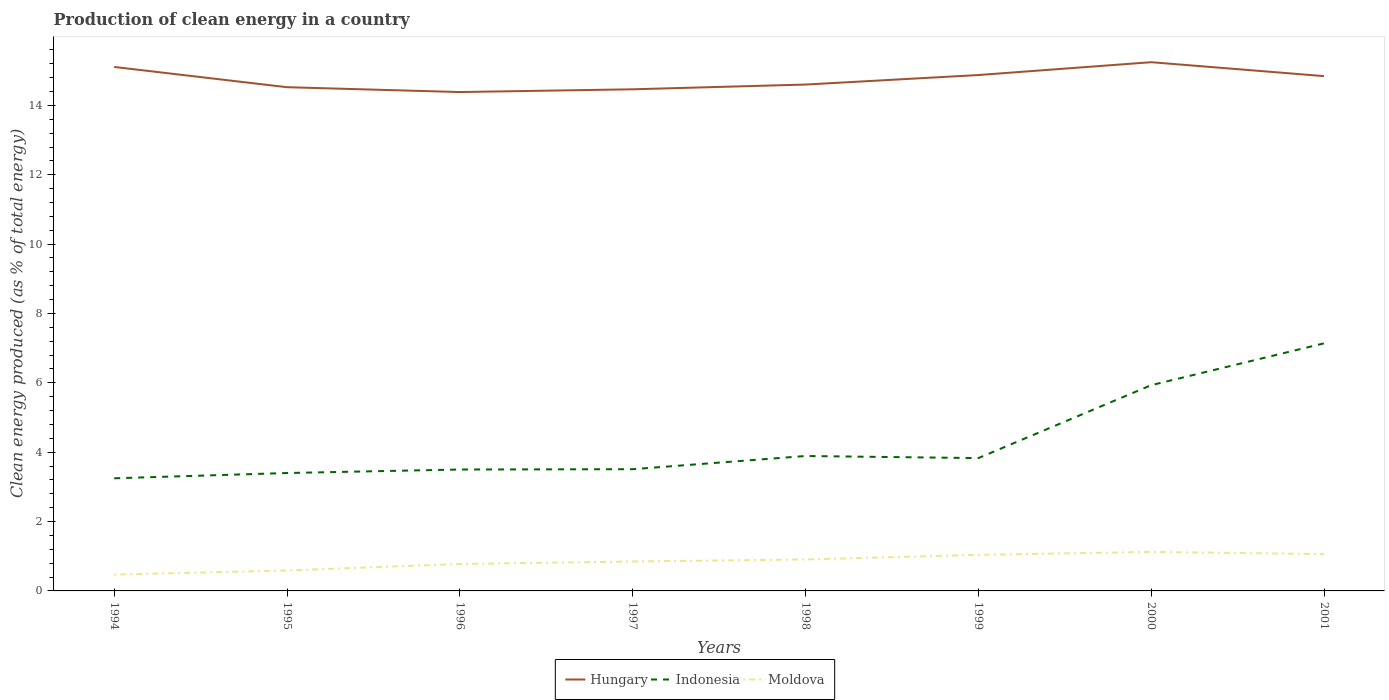Does the line corresponding to Hungary intersect with the line corresponding to Moldova?
Offer a very short reply. No. Across all years, what is the maximum percentage of clean energy produced in Indonesia?
Keep it short and to the point. 3.25. What is the total percentage of clean energy produced in Moldova in the graph?
Keep it short and to the point. -0.26. What is the difference between the highest and the second highest percentage of clean energy produced in Moldova?
Keep it short and to the point. 0.65. What is the difference between the highest and the lowest percentage of clean energy produced in Hungary?
Ensure brevity in your answer.  4. How many years are there in the graph?
Keep it short and to the point. 8. Are the values on the major ticks of Y-axis written in scientific E-notation?
Give a very brief answer. No. Does the graph contain any zero values?
Keep it short and to the point. No. Does the graph contain grids?
Your answer should be very brief. No. How many legend labels are there?
Provide a short and direct response. 3. How are the legend labels stacked?
Your response must be concise. Horizontal. What is the title of the graph?
Your answer should be compact. Production of clean energy in a country. What is the label or title of the X-axis?
Offer a very short reply. Years. What is the label or title of the Y-axis?
Offer a terse response. Clean energy produced (as % of total energy). What is the Clean energy produced (as % of total energy) in Hungary in 1994?
Your answer should be compact. 15.11. What is the Clean energy produced (as % of total energy) in Indonesia in 1994?
Your response must be concise. 3.25. What is the Clean energy produced (as % of total energy) in Moldova in 1994?
Your response must be concise. 0.47. What is the Clean energy produced (as % of total energy) in Hungary in 1995?
Offer a very short reply. 14.52. What is the Clean energy produced (as % of total energy) in Indonesia in 1995?
Keep it short and to the point. 3.4. What is the Clean energy produced (as % of total energy) in Moldova in 1995?
Give a very brief answer. 0.59. What is the Clean energy produced (as % of total energy) in Hungary in 1996?
Ensure brevity in your answer.  14.39. What is the Clean energy produced (as % of total energy) in Indonesia in 1996?
Your answer should be very brief. 3.5. What is the Clean energy produced (as % of total energy) in Moldova in 1996?
Provide a short and direct response. 0.78. What is the Clean energy produced (as % of total energy) in Hungary in 1997?
Make the answer very short. 14.46. What is the Clean energy produced (as % of total energy) of Indonesia in 1997?
Provide a succinct answer. 3.51. What is the Clean energy produced (as % of total energy) of Moldova in 1997?
Keep it short and to the point. 0.85. What is the Clean energy produced (as % of total energy) of Hungary in 1998?
Your answer should be very brief. 14.6. What is the Clean energy produced (as % of total energy) in Indonesia in 1998?
Keep it short and to the point. 3.89. What is the Clean energy produced (as % of total energy) in Moldova in 1998?
Give a very brief answer. 0.91. What is the Clean energy produced (as % of total energy) of Hungary in 1999?
Your response must be concise. 14.88. What is the Clean energy produced (as % of total energy) in Indonesia in 1999?
Offer a terse response. 3.83. What is the Clean energy produced (as % of total energy) in Moldova in 1999?
Keep it short and to the point. 1.04. What is the Clean energy produced (as % of total energy) of Hungary in 2000?
Your answer should be very brief. 15.25. What is the Clean energy produced (as % of total energy) in Indonesia in 2000?
Ensure brevity in your answer.  5.93. What is the Clean energy produced (as % of total energy) in Moldova in 2000?
Your answer should be compact. 1.12. What is the Clean energy produced (as % of total energy) in Hungary in 2001?
Keep it short and to the point. 14.84. What is the Clean energy produced (as % of total energy) in Indonesia in 2001?
Keep it short and to the point. 7.14. What is the Clean energy produced (as % of total energy) in Moldova in 2001?
Your answer should be compact. 1.06. Across all years, what is the maximum Clean energy produced (as % of total energy) of Hungary?
Your answer should be very brief. 15.25. Across all years, what is the maximum Clean energy produced (as % of total energy) of Indonesia?
Provide a succinct answer. 7.14. Across all years, what is the maximum Clean energy produced (as % of total energy) of Moldova?
Ensure brevity in your answer.  1.12. Across all years, what is the minimum Clean energy produced (as % of total energy) in Hungary?
Offer a terse response. 14.39. Across all years, what is the minimum Clean energy produced (as % of total energy) of Indonesia?
Provide a succinct answer. 3.25. Across all years, what is the minimum Clean energy produced (as % of total energy) of Moldova?
Offer a terse response. 0.47. What is the total Clean energy produced (as % of total energy) in Hungary in the graph?
Keep it short and to the point. 118.05. What is the total Clean energy produced (as % of total energy) in Indonesia in the graph?
Your answer should be compact. 34.45. What is the total Clean energy produced (as % of total energy) in Moldova in the graph?
Your response must be concise. 6.82. What is the difference between the Clean energy produced (as % of total energy) in Hungary in 1994 and that in 1995?
Keep it short and to the point. 0.58. What is the difference between the Clean energy produced (as % of total energy) of Indonesia in 1994 and that in 1995?
Offer a very short reply. -0.15. What is the difference between the Clean energy produced (as % of total energy) of Moldova in 1994 and that in 1995?
Give a very brief answer. -0.12. What is the difference between the Clean energy produced (as % of total energy) in Hungary in 1994 and that in 1996?
Provide a succinct answer. 0.72. What is the difference between the Clean energy produced (as % of total energy) in Indonesia in 1994 and that in 1996?
Ensure brevity in your answer.  -0.25. What is the difference between the Clean energy produced (as % of total energy) in Moldova in 1994 and that in 1996?
Your response must be concise. -0.31. What is the difference between the Clean energy produced (as % of total energy) of Hungary in 1994 and that in 1997?
Offer a terse response. 0.64. What is the difference between the Clean energy produced (as % of total energy) in Indonesia in 1994 and that in 1997?
Offer a terse response. -0.26. What is the difference between the Clean energy produced (as % of total energy) of Moldova in 1994 and that in 1997?
Your answer should be compact. -0.38. What is the difference between the Clean energy produced (as % of total energy) in Hungary in 1994 and that in 1998?
Offer a very short reply. 0.51. What is the difference between the Clean energy produced (as % of total energy) of Indonesia in 1994 and that in 1998?
Provide a succinct answer. -0.64. What is the difference between the Clean energy produced (as % of total energy) of Moldova in 1994 and that in 1998?
Your response must be concise. -0.44. What is the difference between the Clean energy produced (as % of total energy) of Hungary in 1994 and that in 1999?
Your response must be concise. 0.23. What is the difference between the Clean energy produced (as % of total energy) of Indonesia in 1994 and that in 1999?
Offer a terse response. -0.58. What is the difference between the Clean energy produced (as % of total energy) in Moldova in 1994 and that in 1999?
Provide a short and direct response. -0.57. What is the difference between the Clean energy produced (as % of total energy) of Hungary in 1994 and that in 2000?
Make the answer very short. -0.14. What is the difference between the Clean energy produced (as % of total energy) of Indonesia in 1994 and that in 2000?
Provide a short and direct response. -2.68. What is the difference between the Clean energy produced (as % of total energy) in Moldova in 1994 and that in 2000?
Your answer should be very brief. -0.65. What is the difference between the Clean energy produced (as % of total energy) of Hungary in 1994 and that in 2001?
Offer a very short reply. 0.26. What is the difference between the Clean energy produced (as % of total energy) of Indonesia in 1994 and that in 2001?
Your answer should be very brief. -3.89. What is the difference between the Clean energy produced (as % of total energy) in Moldova in 1994 and that in 2001?
Ensure brevity in your answer.  -0.59. What is the difference between the Clean energy produced (as % of total energy) of Hungary in 1995 and that in 1996?
Keep it short and to the point. 0.14. What is the difference between the Clean energy produced (as % of total energy) of Indonesia in 1995 and that in 1996?
Provide a short and direct response. -0.1. What is the difference between the Clean energy produced (as % of total energy) in Moldova in 1995 and that in 1996?
Your response must be concise. -0.19. What is the difference between the Clean energy produced (as % of total energy) in Hungary in 1995 and that in 1997?
Make the answer very short. 0.06. What is the difference between the Clean energy produced (as % of total energy) of Indonesia in 1995 and that in 1997?
Provide a short and direct response. -0.11. What is the difference between the Clean energy produced (as % of total energy) in Moldova in 1995 and that in 1997?
Make the answer very short. -0.26. What is the difference between the Clean energy produced (as % of total energy) in Hungary in 1995 and that in 1998?
Ensure brevity in your answer.  -0.08. What is the difference between the Clean energy produced (as % of total energy) in Indonesia in 1995 and that in 1998?
Ensure brevity in your answer.  -0.49. What is the difference between the Clean energy produced (as % of total energy) of Moldova in 1995 and that in 1998?
Ensure brevity in your answer.  -0.32. What is the difference between the Clean energy produced (as % of total energy) in Hungary in 1995 and that in 1999?
Your response must be concise. -0.35. What is the difference between the Clean energy produced (as % of total energy) in Indonesia in 1995 and that in 1999?
Provide a short and direct response. -0.43. What is the difference between the Clean energy produced (as % of total energy) in Moldova in 1995 and that in 1999?
Your answer should be compact. -0.45. What is the difference between the Clean energy produced (as % of total energy) in Hungary in 1995 and that in 2000?
Offer a very short reply. -0.72. What is the difference between the Clean energy produced (as % of total energy) in Indonesia in 1995 and that in 2000?
Provide a short and direct response. -2.53. What is the difference between the Clean energy produced (as % of total energy) of Moldova in 1995 and that in 2000?
Provide a succinct answer. -0.53. What is the difference between the Clean energy produced (as % of total energy) of Hungary in 1995 and that in 2001?
Ensure brevity in your answer.  -0.32. What is the difference between the Clean energy produced (as % of total energy) in Indonesia in 1995 and that in 2001?
Offer a terse response. -3.74. What is the difference between the Clean energy produced (as % of total energy) of Moldova in 1995 and that in 2001?
Your response must be concise. -0.47. What is the difference between the Clean energy produced (as % of total energy) of Hungary in 1996 and that in 1997?
Provide a short and direct response. -0.08. What is the difference between the Clean energy produced (as % of total energy) of Indonesia in 1996 and that in 1997?
Offer a terse response. -0.01. What is the difference between the Clean energy produced (as % of total energy) in Moldova in 1996 and that in 1997?
Your answer should be compact. -0.07. What is the difference between the Clean energy produced (as % of total energy) of Hungary in 1996 and that in 1998?
Offer a terse response. -0.22. What is the difference between the Clean energy produced (as % of total energy) of Indonesia in 1996 and that in 1998?
Give a very brief answer. -0.39. What is the difference between the Clean energy produced (as % of total energy) of Moldova in 1996 and that in 1998?
Ensure brevity in your answer.  -0.13. What is the difference between the Clean energy produced (as % of total energy) in Hungary in 1996 and that in 1999?
Give a very brief answer. -0.49. What is the difference between the Clean energy produced (as % of total energy) in Indonesia in 1996 and that in 1999?
Offer a terse response. -0.33. What is the difference between the Clean energy produced (as % of total energy) in Moldova in 1996 and that in 1999?
Provide a succinct answer. -0.26. What is the difference between the Clean energy produced (as % of total energy) of Hungary in 1996 and that in 2000?
Give a very brief answer. -0.86. What is the difference between the Clean energy produced (as % of total energy) in Indonesia in 1996 and that in 2000?
Ensure brevity in your answer.  -2.43. What is the difference between the Clean energy produced (as % of total energy) of Moldova in 1996 and that in 2000?
Your answer should be very brief. -0.35. What is the difference between the Clean energy produced (as % of total energy) of Hungary in 1996 and that in 2001?
Provide a succinct answer. -0.46. What is the difference between the Clean energy produced (as % of total energy) of Indonesia in 1996 and that in 2001?
Offer a terse response. -3.64. What is the difference between the Clean energy produced (as % of total energy) in Moldova in 1996 and that in 2001?
Keep it short and to the point. -0.29. What is the difference between the Clean energy produced (as % of total energy) of Hungary in 1997 and that in 1998?
Make the answer very short. -0.14. What is the difference between the Clean energy produced (as % of total energy) of Indonesia in 1997 and that in 1998?
Offer a very short reply. -0.38. What is the difference between the Clean energy produced (as % of total energy) in Moldova in 1997 and that in 1998?
Provide a succinct answer. -0.06. What is the difference between the Clean energy produced (as % of total energy) in Hungary in 1997 and that in 1999?
Your answer should be very brief. -0.41. What is the difference between the Clean energy produced (as % of total energy) in Indonesia in 1997 and that in 1999?
Make the answer very short. -0.32. What is the difference between the Clean energy produced (as % of total energy) in Moldova in 1997 and that in 1999?
Provide a short and direct response. -0.19. What is the difference between the Clean energy produced (as % of total energy) in Hungary in 1997 and that in 2000?
Provide a short and direct response. -0.78. What is the difference between the Clean energy produced (as % of total energy) of Indonesia in 1997 and that in 2000?
Your response must be concise. -2.42. What is the difference between the Clean energy produced (as % of total energy) in Moldova in 1997 and that in 2000?
Provide a short and direct response. -0.28. What is the difference between the Clean energy produced (as % of total energy) in Hungary in 1997 and that in 2001?
Your response must be concise. -0.38. What is the difference between the Clean energy produced (as % of total energy) in Indonesia in 1997 and that in 2001?
Your answer should be very brief. -3.63. What is the difference between the Clean energy produced (as % of total energy) of Moldova in 1997 and that in 2001?
Offer a very short reply. -0.21. What is the difference between the Clean energy produced (as % of total energy) of Hungary in 1998 and that in 1999?
Offer a very short reply. -0.27. What is the difference between the Clean energy produced (as % of total energy) of Indonesia in 1998 and that in 1999?
Provide a succinct answer. 0.06. What is the difference between the Clean energy produced (as % of total energy) in Moldova in 1998 and that in 1999?
Give a very brief answer. -0.13. What is the difference between the Clean energy produced (as % of total energy) of Hungary in 1998 and that in 2000?
Make the answer very short. -0.64. What is the difference between the Clean energy produced (as % of total energy) in Indonesia in 1998 and that in 2000?
Offer a very short reply. -2.04. What is the difference between the Clean energy produced (as % of total energy) of Moldova in 1998 and that in 2000?
Provide a succinct answer. -0.22. What is the difference between the Clean energy produced (as % of total energy) in Hungary in 1998 and that in 2001?
Give a very brief answer. -0.24. What is the difference between the Clean energy produced (as % of total energy) of Indonesia in 1998 and that in 2001?
Provide a succinct answer. -3.25. What is the difference between the Clean energy produced (as % of total energy) of Moldova in 1998 and that in 2001?
Give a very brief answer. -0.15. What is the difference between the Clean energy produced (as % of total energy) of Hungary in 1999 and that in 2000?
Offer a very short reply. -0.37. What is the difference between the Clean energy produced (as % of total energy) of Indonesia in 1999 and that in 2000?
Your answer should be compact. -2.1. What is the difference between the Clean energy produced (as % of total energy) of Moldova in 1999 and that in 2000?
Your answer should be compact. -0.08. What is the difference between the Clean energy produced (as % of total energy) in Hungary in 1999 and that in 2001?
Offer a very short reply. 0.03. What is the difference between the Clean energy produced (as % of total energy) in Indonesia in 1999 and that in 2001?
Keep it short and to the point. -3.31. What is the difference between the Clean energy produced (as % of total energy) in Moldova in 1999 and that in 2001?
Make the answer very short. -0.02. What is the difference between the Clean energy produced (as % of total energy) of Hungary in 2000 and that in 2001?
Ensure brevity in your answer.  0.4. What is the difference between the Clean energy produced (as % of total energy) of Indonesia in 2000 and that in 2001?
Provide a succinct answer. -1.21. What is the difference between the Clean energy produced (as % of total energy) of Moldova in 2000 and that in 2001?
Keep it short and to the point. 0.06. What is the difference between the Clean energy produced (as % of total energy) in Hungary in 1994 and the Clean energy produced (as % of total energy) in Indonesia in 1995?
Give a very brief answer. 11.71. What is the difference between the Clean energy produced (as % of total energy) of Hungary in 1994 and the Clean energy produced (as % of total energy) of Moldova in 1995?
Offer a terse response. 14.52. What is the difference between the Clean energy produced (as % of total energy) of Indonesia in 1994 and the Clean energy produced (as % of total energy) of Moldova in 1995?
Offer a very short reply. 2.66. What is the difference between the Clean energy produced (as % of total energy) of Hungary in 1994 and the Clean energy produced (as % of total energy) of Indonesia in 1996?
Offer a very short reply. 11.61. What is the difference between the Clean energy produced (as % of total energy) of Hungary in 1994 and the Clean energy produced (as % of total energy) of Moldova in 1996?
Make the answer very short. 14.33. What is the difference between the Clean energy produced (as % of total energy) of Indonesia in 1994 and the Clean energy produced (as % of total energy) of Moldova in 1996?
Give a very brief answer. 2.47. What is the difference between the Clean energy produced (as % of total energy) of Hungary in 1994 and the Clean energy produced (as % of total energy) of Indonesia in 1997?
Your answer should be very brief. 11.6. What is the difference between the Clean energy produced (as % of total energy) in Hungary in 1994 and the Clean energy produced (as % of total energy) in Moldova in 1997?
Your answer should be very brief. 14.26. What is the difference between the Clean energy produced (as % of total energy) in Indonesia in 1994 and the Clean energy produced (as % of total energy) in Moldova in 1997?
Provide a short and direct response. 2.4. What is the difference between the Clean energy produced (as % of total energy) in Hungary in 1994 and the Clean energy produced (as % of total energy) in Indonesia in 1998?
Offer a terse response. 11.22. What is the difference between the Clean energy produced (as % of total energy) of Hungary in 1994 and the Clean energy produced (as % of total energy) of Moldova in 1998?
Offer a very short reply. 14.2. What is the difference between the Clean energy produced (as % of total energy) of Indonesia in 1994 and the Clean energy produced (as % of total energy) of Moldova in 1998?
Offer a very short reply. 2.34. What is the difference between the Clean energy produced (as % of total energy) of Hungary in 1994 and the Clean energy produced (as % of total energy) of Indonesia in 1999?
Your answer should be very brief. 11.28. What is the difference between the Clean energy produced (as % of total energy) of Hungary in 1994 and the Clean energy produced (as % of total energy) of Moldova in 1999?
Offer a terse response. 14.07. What is the difference between the Clean energy produced (as % of total energy) in Indonesia in 1994 and the Clean energy produced (as % of total energy) in Moldova in 1999?
Ensure brevity in your answer.  2.21. What is the difference between the Clean energy produced (as % of total energy) of Hungary in 1994 and the Clean energy produced (as % of total energy) of Indonesia in 2000?
Offer a very short reply. 9.18. What is the difference between the Clean energy produced (as % of total energy) of Hungary in 1994 and the Clean energy produced (as % of total energy) of Moldova in 2000?
Offer a very short reply. 13.98. What is the difference between the Clean energy produced (as % of total energy) of Indonesia in 1994 and the Clean energy produced (as % of total energy) of Moldova in 2000?
Offer a very short reply. 2.12. What is the difference between the Clean energy produced (as % of total energy) in Hungary in 1994 and the Clean energy produced (as % of total energy) in Indonesia in 2001?
Provide a succinct answer. 7.97. What is the difference between the Clean energy produced (as % of total energy) in Hungary in 1994 and the Clean energy produced (as % of total energy) in Moldova in 2001?
Offer a very short reply. 14.05. What is the difference between the Clean energy produced (as % of total energy) in Indonesia in 1994 and the Clean energy produced (as % of total energy) in Moldova in 2001?
Offer a terse response. 2.19. What is the difference between the Clean energy produced (as % of total energy) of Hungary in 1995 and the Clean energy produced (as % of total energy) of Indonesia in 1996?
Your answer should be very brief. 11.02. What is the difference between the Clean energy produced (as % of total energy) in Hungary in 1995 and the Clean energy produced (as % of total energy) in Moldova in 1996?
Offer a very short reply. 13.75. What is the difference between the Clean energy produced (as % of total energy) in Indonesia in 1995 and the Clean energy produced (as % of total energy) in Moldova in 1996?
Provide a short and direct response. 2.62. What is the difference between the Clean energy produced (as % of total energy) in Hungary in 1995 and the Clean energy produced (as % of total energy) in Indonesia in 1997?
Give a very brief answer. 11.01. What is the difference between the Clean energy produced (as % of total energy) of Hungary in 1995 and the Clean energy produced (as % of total energy) of Moldova in 1997?
Provide a succinct answer. 13.68. What is the difference between the Clean energy produced (as % of total energy) in Indonesia in 1995 and the Clean energy produced (as % of total energy) in Moldova in 1997?
Your response must be concise. 2.55. What is the difference between the Clean energy produced (as % of total energy) of Hungary in 1995 and the Clean energy produced (as % of total energy) of Indonesia in 1998?
Make the answer very short. 10.63. What is the difference between the Clean energy produced (as % of total energy) of Hungary in 1995 and the Clean energy produced (as % of total energy) of Moldova in 1998?
Keep it short and to the point. 13.62. What is the difference between the Clean energy produced (as % of total energy) of Indonesia in 1995 and the Clean energy produced (as % of total energy) of Moldova in 1998?
Your answer should be very brief. 2.49. What is the difference between the Clean energy produced (as % of total energy) of Hungary in 1995 and the Clean energy produced (as % of total energy) of Indonesia in 1999?
Provide a short and direct response. 10.69. What is the difference between the Clean energy produced (as % of total energy) of Hungary in 1995 and the Clean energy produced (as % of total energy) of Moldova in 1999?
Ensure brevity in your answer.  13.48. What is the difference between the Clean energy produced (as % of total energy) in Indonesia in 1995 and the Clean energy produced (as % of total energy) in Moldova in 1999?
Give a very brief answer. 2.36. What is the difference between the Clean energy produced (as % of total energy) in Hungary in 1995 and the Clean energy produced (as % of total energy) in Indonesia in 2000?
Offer a terse response. 8.59. What is the difference between the Clean energy produced (as % of total energy) in Hungary in 1995 and the Clean energy produced (as % of total energy) in Moldova in 2000?
Your answer should be very brief. 13.4. What is the difference between the Clean energy produced (as % of total energy) of Indonesia in 1995 and the Clean energy produced (as % of total energy) of Moldova in 2000?
Provide a short and direct response. 2.28. What is the difference between the Clean energy produced (as % of total energy) in Hungary in 1995 and the Clean energy produced (as % of total energy) in Indonesia in 2001?
Make the answer very short. 7.39. What is the difference between the Clean energy produced (as % of total energy) in Hungary in 1995 and the Clean energy produced (as % of total energy) in Moldova in 2001?
Give a very brief answer. 13.46. What is the difference between the Clean energy produced (as % of total energy) of Indonesia in 1995 and the Clean energy produced (as % of total energy) of Moldova in 2001?
Provide a short and direct response. 2.34. What is the difference between the Clean energy produced (as % of total energy) in Hungary in 1996 and the Clean energy produced (as % of total energy) in Indonesia in 1997?
Your answer should be compact. 10.88. What is the difference between the Clean energy produced (as % of total energy) in Hungary in 1996 and the Clean energy produced (as % of total energy) in Moldova in 1997?
Offer a terse response. 13.54. What is the difference between the Clean energy produced (as % of total energy) in Indonesia in 1996 and the Clean energy produced (as % of total energy) in Moldova in 1997?
Your response must be concise. 2.65. What is the difference between the Clean energy produced (as % of total energy) in Hungary in 1996 and the Clean energy produced (as % of total energy) in Indonesia in 1998?
Offer a very short reply. 10.49. What is the difference between the Clean energy produced (as % of total energy) of Hungary in 1996 and the Clean energy produced (as % of total energy) of Moldova in 1998?
Offer a terse response. 13.48. What is the difference between the Clean energy produced (as % of total energy) in Indonesia in 1996 and the Clean energy produced (as % of total energy) in Moldova in 1998?
Give a very brief answer. 2.59. What is the difference between the Clean energy produced (as % of total energy) of Hungary in 1996 and the Clean energy produced (as % of total energy) of Indonesia in 1999?
Provide a short and direct response. 10.56. What is the difference between the Clean energy produced (as % of total energy) in Hungary in 1996 and the Clean energy produced (as % of total energy) in Moldova in 1999?
Provide a succinct answer. 13.34. What is the difference between the Clean energy produced (as % of total energy) of Indonesia in 1996 and the Clean energy produced (as % of total energy) of Moldova in 1999?
Give a very brief answer. 2.46. What is the difference between the Clean energy produced (as % of total energy) in Hungary in 1996 and the Clean energy produced (as % of total energy) in Indonesia in 2000?
Give a very brief answer. 8.45. What is the difference between the Clean energy produced (as % of total energy) in Hungary in 1996 and the Clean energy produced (as % of total energy) in Moldova in 2000?
Your answer should be compact. 13.26. What is the difference between the Clean energy produced (as % of total energy) of Indonesia in 1996 and the Clean energy produced (as % of total energy) of Moldova in 2000?
Your answer should be compact. 2.38. What is the difference between the Clean energy produced (as % of total energy) of Hungary in 1996 and the Clean energy produced (as % of total energy) of Indonesia in 2001?
Your answer should be compact. 7.25. What is the difference between the Clean energy produced (as % of total energy) of Hungary in 1996 and the Clean energy produced (as % of total energy) of Moldova in 2001?
Ensure brevity in your answer.  13.32. What is the difference between the Clean energy produced (as % of total energy) of Indonesia in 1996 and the Clean energy produced (as % of total energy) of Moldova in 2001?
Provide a short and direct response. 2.44. What is the difference between the Clean energy produced (as % of total energy) of Hungary in 1997 and the Clean energy produced (as % of total energy) of Indonesia in 1998?
Keep it short and to the point. 10.57. What is the difference between the Clean energy produced (as % of total energy) in Hungary in 1997 and the Clean energy produced (as % of total energy) in Moldova in 1998?
Provide a succinct answer. 13.56. What is the difference between the Clean energy produced (as % of total energy) of Indonesia in 1997 and the Clean energy produced (as % of total energy) of Moldova in 1998?
Your answer should be very brief. 2.6. What is the difference between the Clean energy produced (as % of total energy) in Hungary in 1997 and the Clean energy produced (as % of total energy) in Indonesia in 1999?
Provide a short and direct response. 10.63. What is the difference between the Clean energy produced (as % of total energy) of Hungary in 1997 and the Clean energy produced (as % of total energy) of Moldova in 1999?
Keep it short and to the point. 13.42. What is the difference between the Clean energy produced (as % of total energy) in Indonesia in 1997 and the Clean energy produced (as % of total energy) in Moldova in 1999?
Your answer should be very brief. 2.47. What is the difference between the Clean energy produced (as % of total energy) in Hungary in 1997 and the Clean energy produced (as % of total energy) in Indonesia in 2000?
Ensure brevity in your answer.  8.53. What is the difference between the Clean energy produced (as % of total energy) in Hungary in 1997 and the Clean energy produced (as % of total energy) in Moldova in 2000?
Your answer should be compact. 13.34. What is the difference between the Clean energy produced (as % of total energy) in Indonesia in 1997 and the Clean energy produced (as % of total energy) in Moldova in 2000?
Give a very brief answer. 2.39. What is the difference between the Clean energy produced (as % of total energy) in Hungary in 1997 and the Clean energy produced (as % of total energy) in Indonesia in 2001?
Give a very brief answer. 7.33. What is the difference between the Clean energy produced (as % of total energy) of Hungary in 1997 and the Clean energy produced (as % of total energy) of Moldova in 2001?
Offer a very short reply. 13.4. What is the difference between the Clean energy produced (as % of total energy) in Indonesia in 1997 and the Clean energy produced (as % of total energy) in Moldova in 2001?
Provide a short and direct response. 2.45. What is the difference between the Clean energy produced (as % of total energy) of Hungary in 1998 and the Clean energy produced (as % of total energy) of Indonesia in 1999?
Ensure brevity in your answer.  10.77. What is the difference between the Clean energy produced (as % of total energy) in Hungary in 1998 and the Clean energy produced (as % of total energy) in Moldova in 1999?
Provide a succinct answer. 13.56. What is the difference between the Clean energy produced (as % of total energy) in Indonesia in 1998 and the Clean energy produced (as % of total energy) in Moldova in 1999?
Make the answer very short. 2.85. What is the difference between the Clean energy produced (as % of total energy) of Hungary in 1998 and the Clean energy produced (as % of total energy) of Indonesia in 2000?
Offer a very short reply. 8.67. What is the difference between the Clean energy produced (as % of total energy) of Hungary in 1998 and the Clean energy produced (as % of total energy) of Moldova in 2000?
Provide a succinct answer. 13.48. What is the difference between the Clean energy produced (as % of total energy) of Indonesia in 1998 and the Clean energy produced (as % of total energy) of Moldova in 2000?
Make the answer very short. 2.77. What is the difference between the Clean energy produced (as % of total energy) of Hungary in 1998 and the Clean energy produced (as % of total energy) of Indonesia in 2001?
Offer a terse response. 7.46. What is the difference between the Clean energy produced (as % of total energy) of Hungary in 1998 and the Clean energy produced (as % of total energy) of Moldova in 2001?
Your response must be concise. 13.54. What is the difference between the Clean energy produced (as % of total energy) of Indonesia in 1998 and the Clean energy produced (as % of total energy) of Moldova in 2001?
Your answer should be very brief. 2.83. What is the difference between the Clean energy produced (as % of total energy) in Hungary in 1999 and the Clean energy produced (as % of total energy) in Indonesia in 2000?
Provide a short and direct response. 8.94. What is the difference between the Clean energy produced (as % of total energy) in Hungary in 1999 and the Clean energy produced (as % of total energy) in Moldova in 2000?
Provide a succinct answer. 13.75. What is the difference between the Clean energy produced (as % of total energy) of Indonesia in 1999 and the Clean energy produced (as % of total energy) of Moldova in 2000?
Offer a terse response. 2.71. What is the difference between the Clean energy produced (as % of total energy) of Hungary in 1999 and the Clean energy produced (as % of total energy) of Indonesia in 2001?
Make the answer very short. 7.74. What is the difference between the Clean energy produced (as % of total energy) of Hungary in 1999 and the Clean energy produced (as % of total energy) of Moldova in 2001?
Keep it short and to the point. 13.81. What is the difference between the Clean energy produced (as % of total energy) of Indonesia in 1999 and the Clean energy produced (as % of total energy) of Moldova in 2001?
Your answer should be very brief. 2.77. What is the difference between the Clean energy produced (as % of total energy) in Hungary in 2000 and the Clean energy produced (as % of total energy) in Indonesia in 2001?
Make the answer very short. 8.11. What is the difference between the Clean energy produced (as % of total energy) in Hungary in 2000 and the Clean energy produced (as % of total energy) in Moldova in 2001?
Your response must be concise. 14.18. What is the difference between the Clean energy produced (as % of total energy) in Indonesia in 2000 and the Clean energy produced (as % of total energy) in Moldova in 2001?
Ensure brevity in your answer.  4.87. What is the average Clean energy produced (as % of total energy) of Hungary per year?
Ensure brevity in your answer.  14.76. What is the average Clean energy produced (as % of total energy) in Indonesia per year?
Offer a terse response. 4.31. What is the average Clean energy produced (as % of total energy) in Moldova per year?
Offer a terse response. 0.85. In the year 1994, what is the difference between the Clean energy produced (as % of total energy) of Hungary and Clean energy produced (as % of total energy) of Indonesia?
Your answer should be compact. 11.86. In the year 1994, what is the difference between the Clean energy produced (as % of total energy) in Hungary and Clean energy produced (as % of total energy) in Moldova?
Your answer should be very brief. 14.64. In the year 1994, what is the difference between the Clean energy produced (as % of total energy) of Indonesia and Clean energy produced (as % of total energy) of Moldova?
Offer a terse response. 2.78. In the year 1995, what is the difference between the Clean energy produced (as % of total energy) in Hungary and Clean energy produced (as % of total energy) in Indonesia?
Offer a very short reply. 11.12. In the year 1995, what is the difference between the Clean energy produced (as % of total energy) of Hungary and Clean energy produced (as % of total energy) of Moldova?
Your response must be concise. 13.93. In the year 1995, what is the difference between the Clean energy produced (as % of total energy) of Indonesia and Clean energy produced (as % of total energy) of Moldova?
Your answer should be very brief. 2.81. In the year 1996, what is the difference between the Clean energy produced (as % of total energy) in Hungary and Clean energy produced (as % of total energy) in Indonesia?
Provide a succinct answer. 10.88. In the year 1996, what is the difference between the Clean energy produced (as % of total energy) of Hungary and Clean energy produced (as % of total energy) of Moldova?
Give a very brief answer. 13.61. In the year 1996, what is the difference between the Clean energy produced (as % of total energy) of Indonesia and Clean energy produced (as % of total energy) of Moldova?
Your answer should be very brief. 2.72. In the year 1997, what is the difference between the Clean energy produced (as % of total energy) in Hungary and Clean energy produced (as % of total energy) in Indonesia?
Your response must be concise. 10.95. In the year 1997, what is the difference between the Clean energy produced (as % of total energy) of Hungary and Clean energy produced (as % of total energy) of Moldova?
Make the answer very short. 13.62. In the year 1997, what is the difference between the Clean energy produced (as % of total energy) in Indonesia and Clean energy produced (as % of total energy) in Moldova?
Provide a short and direct response. 2.66. In the year 1998, what is the difference between the Clean energy produced (as % of total energy) in Hungary and Clean energy produced (as % of total energy) in Indonesia?
Provide a succinct answer. 10.71. In the year 1998, what is the difference between the Clean energy produced (as % of total energy) of Hungary and Clean energy produced (as % of total energy) of Moldova?
Provide a succinct answer. 13.69. In the year 1998, what is the difference between the Clean energy produced (as % of total energy) of Indonesia and Clean energy produced (as % of total energy) of Moldova?
Give a very brief answer. 2.98. In the year 1999, what is the difference between the Clean energy produced (as % of total energy) in Hungary and Clean energy produced (as % of total energy) in Indonesia?
Offer a terse response. 11.05. In the year 1999, what is the difference between the Clean energy produced (as % of total energy) in Hungary and Clean energy produced (as % of total energy) in Moldova?
Offer a very short reply. 13.84. In the year 1999, what is the difference between the Clean energy produced (as % of total energy) of Indonesia and Clean energy produced (as % of total energy) of Moldova?
Make the answer very short. 2.79. In the year 2000, what is the difference between the Clean energy produced (as % of total energy) of Hungary and Clean energy produced (as % of total energy) of Indonesia?
Offer a terse response. 9.31. In the year 2000, what is the difference between the Clean energy produced (as % of total energy) in Hungary and Clean energy produced (as % of total energy) in Moldova?
Your answer should be very brief. 14.12. In the year 2000, what is the difference between the Clean energy produced (as % of total energy) of Indonesia and Clean energy produced (as % of total energy) of Moldova?
Make the answer very short. 4.81. In the year 2001, what is the difference between the Clean energy produced (as % of total energy) in Hungary and Clean energy produced (as % of total energy) in Indonesia?
Ensure brevity in your answer.  7.71. In the year 2001, what is the difference between the Clean energy produced (as % of total energy) in Hungary and Clean energy produced (as % of total energy) in Moldova?
Offer a very short reply. 13.78. In the year 2001, what is the difference between the Clean energy produced (as % of total energy) in Indonesia and Clean energy produced (as % of total energy) in Moldova?
Your response must be concise. 6.08. What is the ratio of the Clean energy produced (as % of total energy) of Hungary in 1994 to that in 1995?
Offer a terse response. 1.04. What is the ratio of the Clean energy produced (as % of total energy) of Indonesia in 1994 to that in 1995?
Your answer should be compact. 0.96. What is the ratio of the Clean energy produced (as % of total energy) of Moldova in 1994 to that in 1995?
Provide a succinct answer. 0.8. What is the ratio of the Clean energy produced (as % of total energy) of Hungary in 1994 to that in 1996?
Offer a very short reply. 1.05. What is the ratio of the Clean energy produced (as % of total energy) in Indonesia in 1994 to that in 1996?
Give a very brief answer. 0.93. What is the ratio of the Clean energy produced (as % of total energy) of Moldova in 1994 to that in 1996?
Your response must be concise. 0.61. What is the ratio of the Clean energy produced (as % of total energy) in Hungary in 1994 to that in 1997?
Your answer should be very brief. 1.04. What is the ratio of the Clean energy produced (as % of total energy) in Indonesia in 1994 to that in 1997?
Your response must be concise. 0.93. What is the ratio of the Clean energy produced (as % of total energy) in Moldova in 1994 to that in 1997?
Your answer should be very brief. 0.55. What is the ratio of the Clean energy produced (as % of total energy) of Hungary in 1994 to that in 1998?
Provide a short and direct response. 1.03. What is the ratio of the Clean energy produced (as % of total energy) of Indonesia in 1994 to that in 1998?
Make the answer very short. 0.83. What is the ratio of the Clean energy produced (as % of total energy) in Moldova in 1994 to that in 1998?
Make the answer very short. 0.52. What is the ratio of the Clean energy produced (as % of total energy) of Hungary in 1994 to that in 1999?
Make the answer very short. 1.02. What is the ratio of the Clean energy produced (as % of total energy) in Indonesia in 1994 to that in 1999?
Provide a succinct answer. 0.85. What is the ratio of the Clean energy produced (as % of total energy) in Moldova in 1994 to that in 1999?
Give a very brief answer. 0.45. What is the ratio of the Clean energy produced (as % of total energy) of Hungary in 1994 to that in 2000?
Give a very brief answer. 0.99. What is the ratio of the Clean energy produced (as % of total energy) in Indonesia in 1994 to that in 2000?
Ensure brevity in your answer.  0.55. What is the ratio of the Clean energy produced (as % of total energy) of Moldova in 1994 to that in 2000?
Give a very brief answer. 0.42. What is the ratio of the Clean energy produced (as % of total energy) of Hungary in 1994 to that in 2001?
Make the answer very short. 1.02. What is the ratio of the Clean energy produced (as % of total energy) of Indonesia in 1994 to that in 2001?
Keep it short and to the point. 0.45. What is the ratio of the Clean energy produced (as % of total energy) of Moldova in 1994 to that in 2001?
Keep it short and to the point. 0.44. What is the ratio of the Clean energy produced (as % of total energy) of Hungary in 1995 to that in 1996?
Keep it short and to the point. 1.01. What is the ratio of the Clean energy produced (as % of total energy) of Indonesia in 1995 to that in 1996?
Give a very brief answer. 0.97. What is the ratio of the Clean energy produced (as % of total energy) in Moldova in 1995 to that in 1996?
Keep it short and to the point. 0.76. What is the ratio of the Clean energy produced (as % of total energy) of Hungary in 1995 to that in 1997?
Make the answer very short. 1. What is the ratio of the Clean energy produced (as % of total energy) in Indonesia in 1995 to that in 1997?
Keep it short and to the point. 0.97. What is the ratio of the Clean energy produced (as % of total energy) in Moldova in 1995 to that in 1997?
Ensure brevity in your answer.  0.7. What is the ratio of the Clean energy produced (as % of total energy) of Hungary in 1995 to that in 1998?
Give a very brief answer. 0.99. What is the ratio of the Clean energy produced (as % of total energy) of Indonesia in 1995 to that in 1998?
Offer a terse response. 0.87. What is the ratio of the Clean energy produced (as % of total energy) of Moldova in 1995 to that in 1998?
Your response must be concise. 0.65. What is the ratio of the Clean energy produced (as % of total energy) of Hungary in 1995 to that in 1999?
Give a very brief answer. 0.98. What is the ratio of the Clean energy produced (as % of total energy) in Indonesia in 1995 to that in 1999?
Offer a terse response. 0.89. What is the ratio of the Clean energy produced (as % of total energy) of Moldova in 1995 to that in 1999?
Offer a very short reply. 0.57. What is the ratio of the Clean energy produced (as % of total energy) of Hungary in 1995 to that in 2000?
Offer a very short reply. 0.95. What is the ratio of the Clean energy produced (as % of total energy) of Indonesia in 1995 to that in 2000?
Your answer should be compact. 0.57. What is the ratio of the Clean energy produced (as % of total energy) in Moldova in 1995 to that in 2000?
Your response must be concise. 0.53. What is the ratio of the Clean energy produced (as % of total energy) in Hungary in 1995 to that in 2001?
Keep it short and to the point. 0.98. What is the ratio of the Clean energy produced (as % of total energy) of Indonesia in 1995 to that in 2001?
Keep it short and to the point. 0.48. What is the ratio of the Clean energy produced (as % of total energy) of Moldova in 1995 to that in 2001?
Keep it short and to the point. 0.56. What is the ratio of the Clean energy produced (as % of total energy) in Hungary in 1996 to that in 1997?
Your answer should be very brief. 0.99. What is the ratio of the Clean energy produced (as % of total energy) of Indonesia in 1996 to that in 1997?
Provide a short and direct response. 1. What is the ratio of the Clean energy produced (as % of total energy) of Moldova in 1996 to that in 1997?
Make the answer very short. 0.91. What is the ratio of the Clean energy produced (as % of total energy) of Hungary in 1996 to that in 1998?
Your answer should be very brief. 0.99. What is the ratio of the Clean energy produced (as % of total energy) in Indonesia in 1996 to that in 1998?
Your response must be concise. 0.9. What is the ratio of the Clean energy produced (as % of total energy) in Moldova in 1996 to that in 1998?
Your answer should be compact. 0.86. What is the ratio of the Clean energy produced (as % of total energy) in Hungary in 1996 to that in 1999?
Provide a short and direct response. 0.97. What is the ratio of the Clean energy produced (as % of total energy) of Indonesia in 1996 to that in 1999?
Offer a terse response. 0.91. What is the ratio of the Clean energy produced (as % of total energy) in Moldova in 1996 to that in 1999?
Your answer should be very brief. 0.75. What is the ratio of the Clean energy produced (as % of total energy) in Hungary in 1996 to that in 2000?
Your answer should be very brief. 0.94. What is the ratio of the Clean energy produced (as % of total energy) in Indonesia in 1996 to that in 2000?
Provide a short and direct response. 0.59. What is the ratio of the Clean energy produced (as % of total energy) of Moldova in 1996 to that in 2000?
Give a very brief answer. 0.69. What is the ratio of the Clean energy produced (as % of total energy) in Hungary in 1996 to that in 2001?
Give a very brief answer. 0.97. What is the ratio of the Clean energy produced (as % of total energy) of Indonesia in 1996 to that in 2001?
Provide a short and direct response. 0.49. What is the ratio of the Clean energy produced (as % of total energy) in Moldova in 1996 to that in 2001?
Make the answer very short. 0.73. What is the ratio of the Clean energy produced (as % of total energy) in Hungary in 1997 to that in 1998?
Make the answer very short. 0.99. What is the ratio of the Clean energy produced (as % of total energy) in Indonesia in 1997 to that in 1998?
Provide a short and direct response. 0.9. What is the ratio of the Clean energy produced (as % of total energy) of Moldova in 1997 to that in 1998?
Your response must be concise. 0.94. What is the ratio of the Clean energy produced (as % of total energy) in Hungary in 1997 to that in 1999?
Your answer should be compact. 0.97. What is the ratio of the Clean energy produced (as % of total energy) of Indonesia in 1997 to that in 1999?
Offer a terse response. 0.92. What is the ratio of the Clean energy produced (as % of total energy) of Moldova in 1997 to that in 1999?
Your answer should be very brief. 0.82. What is the ratio of the Clean energy produced (as % of total energy) of Hungary in 1997 to that in 2000?
Ensure brevity in your answer.  0.95. What is the ratio of the Clean energy produced (as % of total energy) of Indonesia in 1997 to that in 2000?
Keep it short and to the point. 0.59. What is the ratio of the Clean energy produced (as % of total energy) of Moldova in 1997 to that in 2000?
Offer a very short reply. 0.75. What is the ratio of the Clean energy produced (as % of total energy) in Hungary in 1997 to that in 2001?
Make the answer very short. 0.97. What is the ratio of the Clean energy produced (as % of total energy) in Indonesia in 1997 to that in 2001?
Offer a very short reply. 0.49. What is the ratio of the Clean energy produced (as % of total energy) of Moldova in 1997 to that in 2001?
Provide a short and direct response. 0.8. What is the ratio of the Clean energy produced (as % of total energy) of Hungary in 1998 to that in 1999?
Offer a very short reply. 0.98. What is the ratio of the Clean energy produced (as % of total energy) of Indonesia in 1998 to that in 1999?
Make the answer very short. 1.02. What is the ratio of the Clean energy produced (as % of total energy) of Moldova in 1998 to that in 1999?
Ensure brevity in your answer.  0.87. What is the ratio of the Clean energy produced (as % of total energy) in Hungary in 1998 to that in 2000?
Your answer should be very brief. 0.96. What is the ratio of the Clean energy produced (as % of total energy) of Indonesia in 1998 to that in 2000?
Offer a terse response. 0.66. What is the ratio of the Clean energy produced (as % of total energy) of Moldova in 1998 to that in 2000?
Give a very brief answer. 0.81. What is the ratio of the Clean energy produced (as % of total energy) of Hungary in 1998 to that in 2001?
Provide a succinct answer. 0.98. What is the ratio of the Clean energy produced (as % of total energy) in Indonesia in 1998 to that in 2001?
Give a very brief answer. 0.55. What is the ratio of the Clean energy produced (as % of total energy) of Moldova in 1998 to that in 2001?
Make the answer very short. 0.85. What is the ratio of the Clean energy produced (as % of total energy) in Hungary in 1999 to that in 2000?
Keep it short and to the point. 0.98. What is the ratio of the Clean energy produced (as % of total energy) of Indonesia in 1999 to that in 2000?
Give a very brief answer. 0.65. What is the ratio of the Clean energy produced (as % of total energy) of Moldova in 1999 to that in 2000?
Your response must be concise. 0.93. What is the ratio of the Clean energy produced (as % of total energy) of Hungary in 1999 to that in 2001?
Your answer should be very brief. 1. What is the ratio of the Clean energy produced (as % of total energy) in Indonesia in 1999 to that in 2001?
Offer a very short reply. 0.54. What is the ratio of the Clean energy produced (as % of total energy) of Moldova in 1999 to that in 2001?
Make the answer very short. 0.98. What is the ratio of the Clean energy produced (as % of total energy) in Hungary in 2000 to that in 2001?
Provide a succinct answer. 1.03. What is the ratio of the Clean energy produced (as % of total energy) of Indonesia in 2000 to that in 2001?
Offer a very short reply. 0.83. What is the ratio of the Clean energy produced (as % of total energy) of Moldova in 2000 to that in 2001?
Give a very brief answer. 1.06. What is the difference between the highest and the second highest Clean energy produced (as % of total energy) of Hungary?
Make the answer very short. 0.14. What is the difference between the highest and the second highest Clean energy produced (as % of total energy) in Indonesia?
Make the answer very short. 1.21. What is the difference between the highest and the second highest Clean energy produced (as % of total energy) of Moldova?
Give a very brief answer. 0.06. What is the difference between the highest and the lowest Clean energy produced (as % of total energy) in Hungary?
Offer a terse response. 0.86. What is the difference between the highest and the lowest Clean energy produced (as % of total energy) in Indonesia?
Make the answer very short. 3.89. What is the difference between the highest and the lowest Clean energy produced (as % of total energy) in Moldova?
Keep it short and to the point. 0.65. 